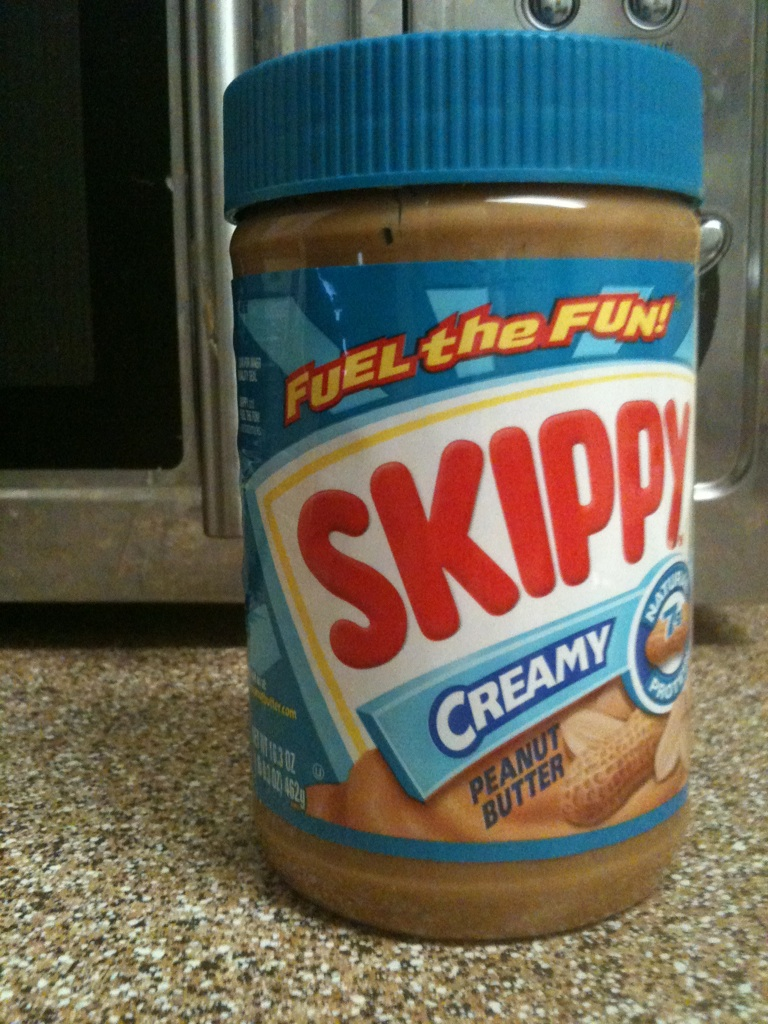What can you tell me about the nutritional value of this peanut butter? This Skippy Creamy Peanut Butter is a source of protein, essential for muscle repair and growth. The jar typically contains information about calories, fat content, and vitamins, providing valuable nutrients in moderate quantities. 